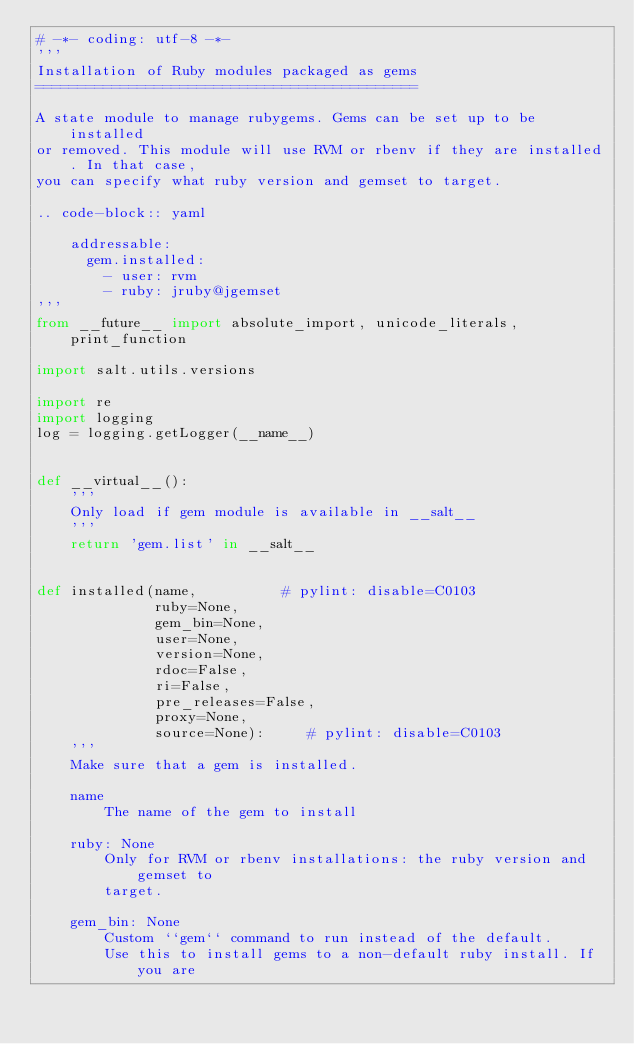<code> <loc_0><loc_0><loc_500><loc_500><_Python_># -*- coding: utf-8 -*-
'''
Installation of Ruby modules packaged as gems
=============================================

A state module to manage rubygems. Gems can be set up to be installed
or removed. This module will use RVM or rbenv if they are installed. In that case,
you can specify what ruby version and gemset to target.

.. code-block:: yaml

    addressable:
      gem.installed:
        - user: rvm
        - ruby: jruby@jgemset
'''
from __future__ import absolute_import, unicode_literals, print_function

import salt.utils.versions

import re
import logging
log = logging.getLogger(__name__)


def __virtual__():
    '''
    Only load if gem module is available in __salt__
    '''
    return 'gem.list' in __salt__


def installed(name,          # pylint: disable=C0103
              ruby=None,
              gem_bin=None,
              user=None,
              version=None,
              rdoc=False,
              ri=False,
              pre_releases=False,
              proxy=None,
              source=None):     # pylint: disable=C0103
    '''
    Make sure that a gem is installed.

    name
        The name of the gem to install

    ruby: None
        Only for RVM or rbenv installations: the ruby version and gemset to
        target.

    gem_bin: None
        Custom ``gem`` command to run instead of the default.
        Use this to install gems to a non-default ruby install. If you are</code> 